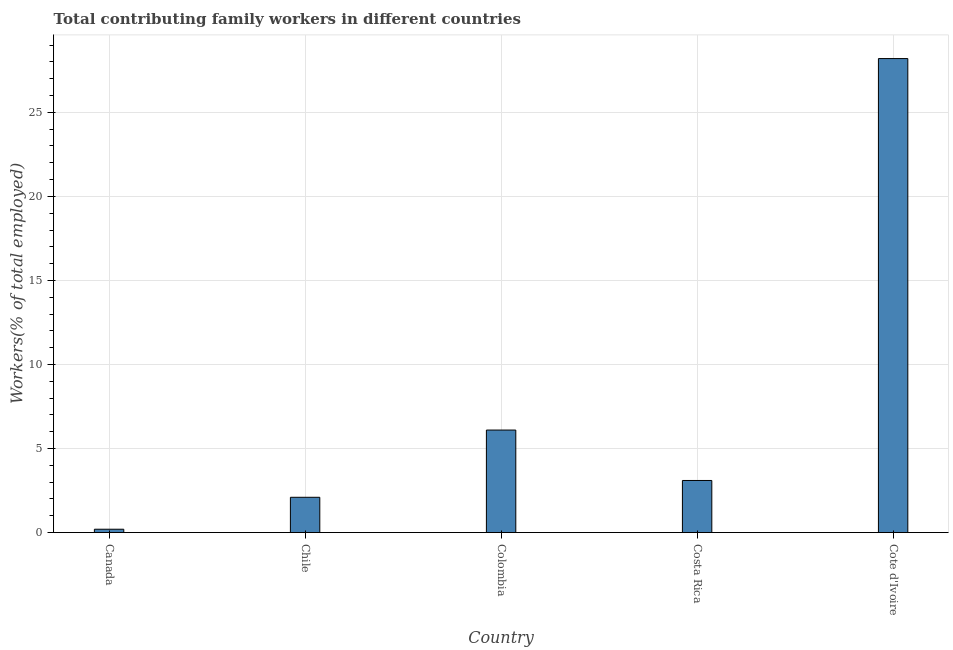What is the title of the graph?
Your answer should be compact. Total contributing family workers in different countries. What is the label or title of the X-axis?
Provide a succinct answer. Country. What is the label or title of the Y-axis?
Offer a very short reply. Workers(% of total employed). What is the contributing family workers in Colombia?
Ensure brevity in your answer.  6.1. Across all countries, what is the maximum contributing family workers?
Ensure brevity in your answer.  28.2. Across all countries, what is the minimum contributing family workers?
Provide a short and direct response. 0.2. In which country was the contributing family workers maximum?
Provide a succinct answer. Cote d'Ivoire. In which country was the contributing family workers minimum?
Offer a terse response. Canada. What is the sum of the contributing family workers?
Provide a succinct answer. 39.7. What is the average contributing family workers per country?
Offer a very short reply. 7.94. What is the median contributing family workers?
Your response must be concise. 3.1. In how many countries, is the contributing family workers greater than 9 %?
Ensure brevity in your answer.  1. What is the ratio of the contributing family workers in Colombia to that in Costa Rica?
Provide a short and direct response. 1.97. What is the difference between the highest and the second highest contributing family workers?
Offer a terse response. 22.1. Is the sum of the contributing family workers in Colombia and Cote d'Ivoire greater than the maximum contributing family workers across all countries?
Offer a very short reply. Yes. What is the difference between the highest and the lowest contributing family workers?
Give a very brief answer. 28. Are all the bars in the graph horizontal?
Make the answer very short. No. Are the values on the major ticks of Y-axis written in scientific E-notation?
Your response must be concise. No. What is the Workers(% of total employed) in Canada?
Your answer should be compact. 0.2. What is the Workers(% of total employed) in Chile?
Ensure brevity in your answer.  2.1. What is the Workers(% of total employed) of Colombia?
Provide a succinct answer. 6.1. What is the Workers(% of total employed) in Costa Rica?
Offer a very short reply. 3.1. What is the Workers(% of total employed) in Cote d'Ivoire?
Offer a very short reply. 28.2. What is the difference between the Workers(% of total employed) in Canada and Colombia?
Offer a terse response. -5.9. What is the difference between the Workers(% of total employed) in Canada and Costa Rica?
Offer a very short reply. -2.9. What is the difference between the Workers(% of total employed) in Chile and Costa Rica?
Offer a very short reply. -1. What is the difference between the Workers(% of total employed) in Chile and Cote d'Ivoire?
Ensure brevity in your answer.  -26.1. What is the difference between the Workers(% of total employed) in Colombia and Cote d'Ivoire?
Ensure brevity in your answer.  -22.1. What is the difference between the Workers(% of total employed) in Costa Rica and Cote d'Ivoire?
Your answer should be compact. -25.1. What is the ratio of the Workers(% of total employed) in Canada to that in Chile?
Provide a succinct answer. 0.1. What is the ratio of the Workers(% of total employed) in Canada to that in Colombia?
Your response must be concise. 0.03. What is the ratio of the Workers(% of total employed) in Canada to that in Costa Rica?
Offer a terse response. 0.07. What is the ratio of the Workers(% of total employed) in Canada to that in Cote d'Ivoire?
Give a very brief answer. 0.01. What is the ratio of the Workers(% of total employed) in Chile to that in Colombia?
Offer a very short reply. 0.34. What is the ratio of the Workers(% of total employed) in Chile to that in Costa Rica?
Your response must be concise. 0.68. What is the ratio of the Workers(% of total employed) in Chile to that in Cote d'Ivoire?
Ensure brevity in your answer.  0.07. What is the ratio of the Workers(% of total employed) in Colombia to that in Costa Rica?
Give a very brief answer. 1.97. What is the ratio of the Workers(% of total employed) in Colombia to that in Cote d'Ivoire?
Your answer should be compact. 0.22. What is the ratio of the Workers(% of total employed) in Costa Rica to that in Cote d'Ivoire?
Offer a terse response. 0.11. 